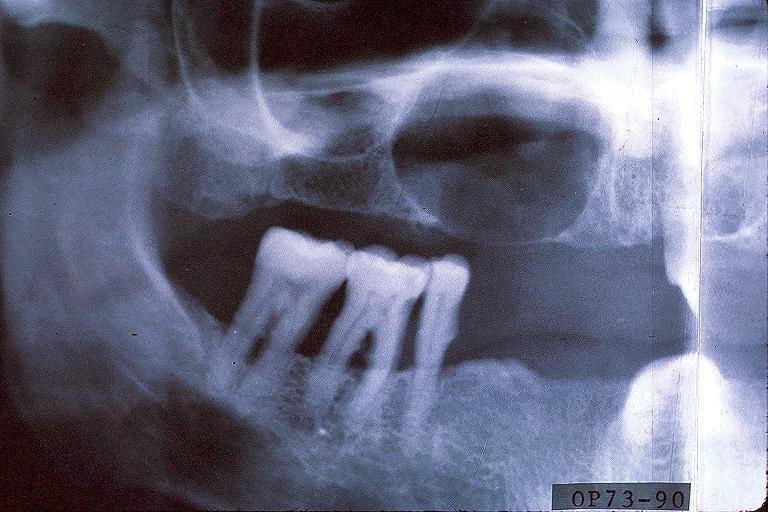s oral present?
Answer the question using a single word or phrase. Yes 